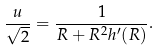<formula> <loc_0><loc_0><loc_500><loc_500>\frac { u } { \sqrt { 2 } } = \frac { 1 } { R + R ^ { 2 } h ^ { \prime } ( R ) } .</formula> 